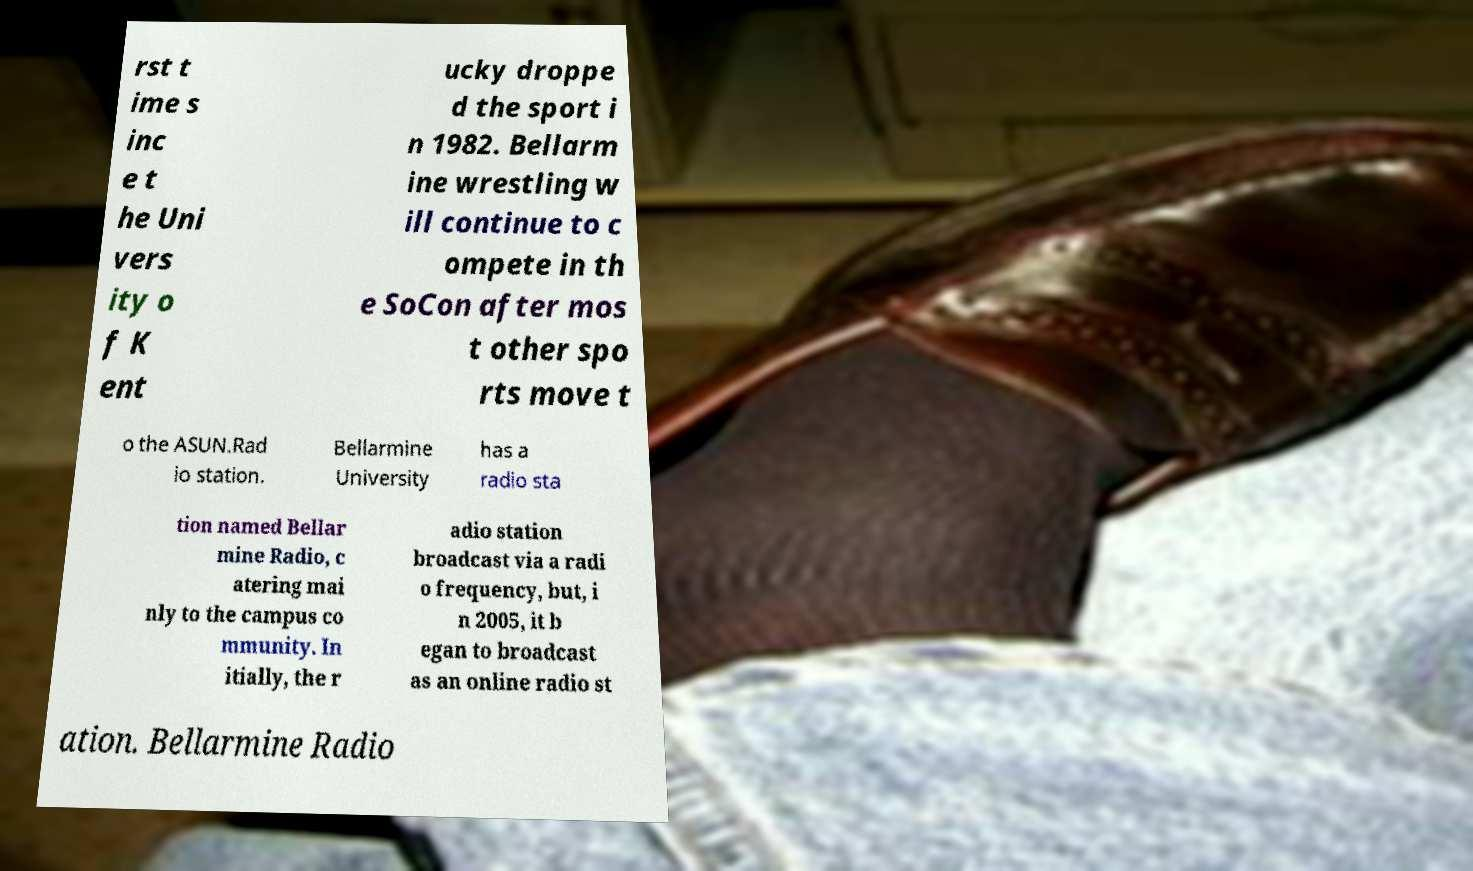Please read and relay the text visible in this image. What does it say? rst t ime s inc e t he Uni vers ity o f K ent ucky droppe d the sport i n 1982. Bellarm ine wrestling w ill continue to c ompete in th e SoCon after mos t other spo rts move t o the ASUN.Rad io station. Bellarmine University has a radio sta tion named Bellar mine Radio, c atering mai nly to the campus co mmunity. In itially, the r adio station broadcast via a radi o frequency, but, i n 2005, it b egan to broadcast as an online radio st ation. Bellarmine Radio 